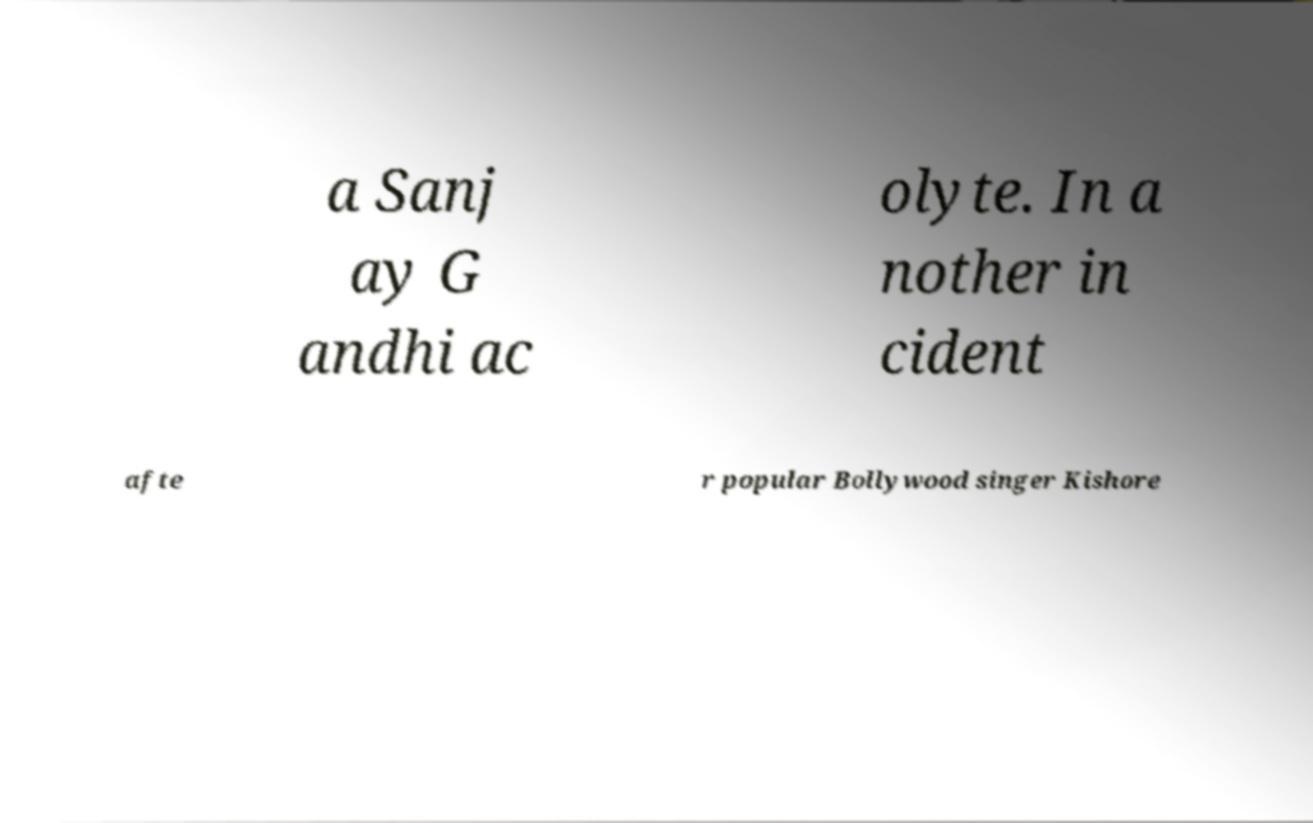Could you extract and type out the text from this image? a Sanj ay G andhi ac olyte. In a nother in cident afte r popular Bollywood singer Kishore 